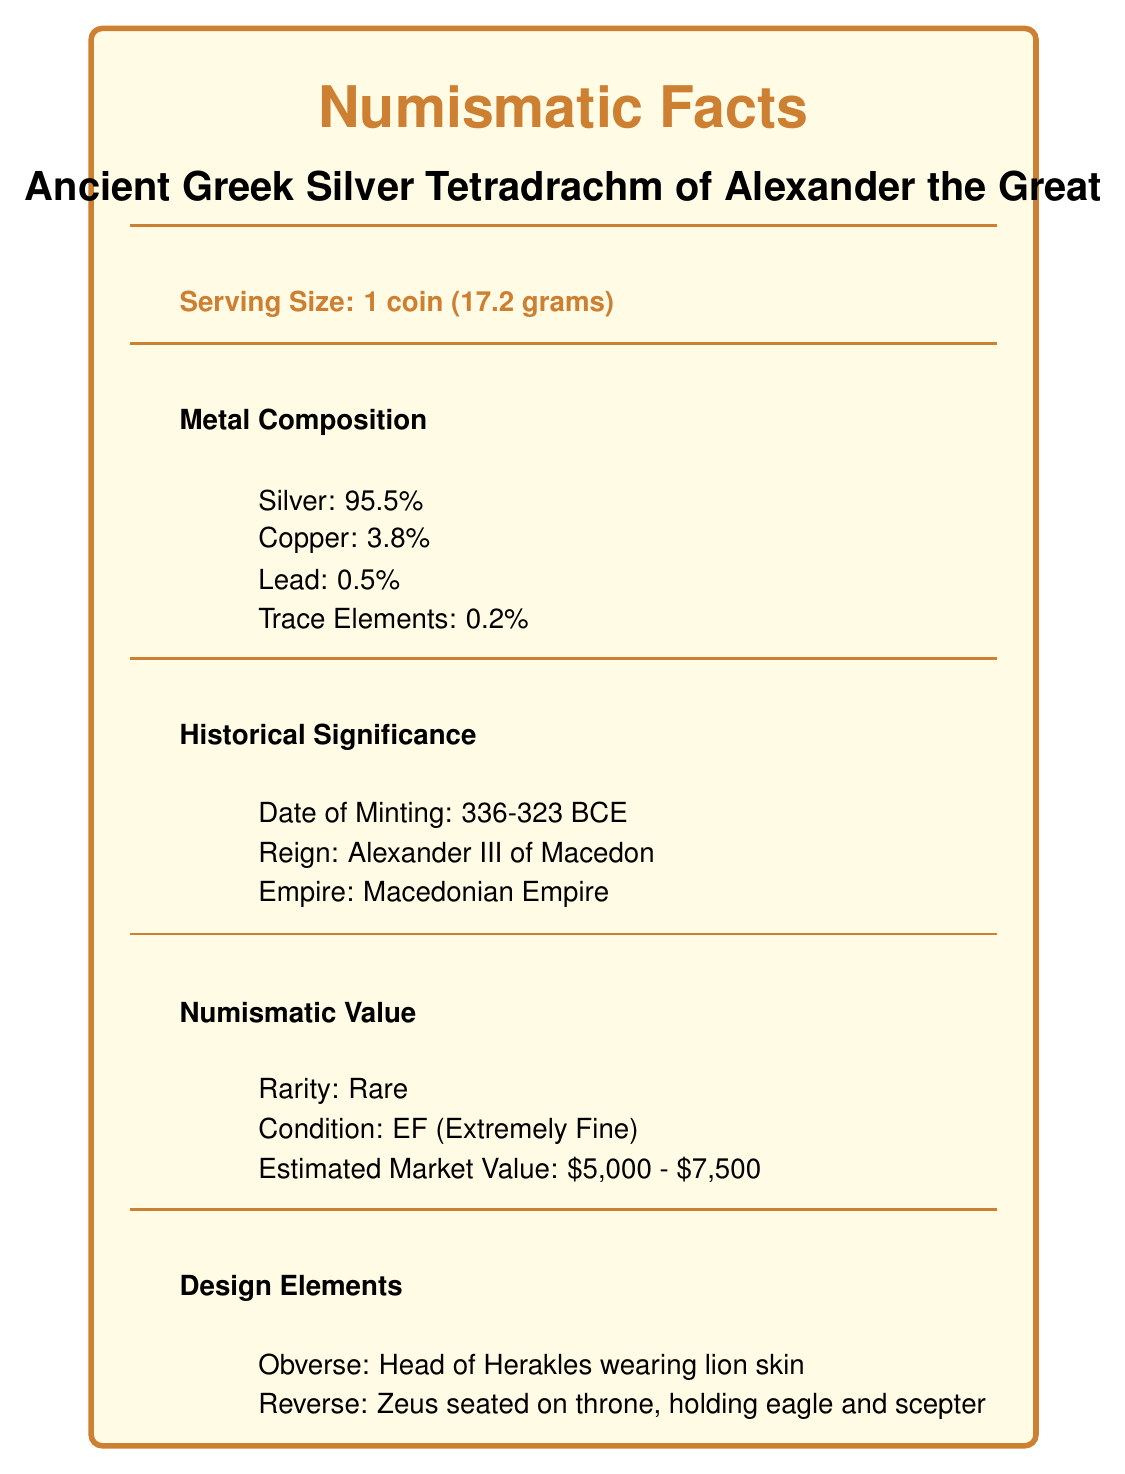what is the serving size of the coin? The serving size is specified in the document as "1 coin (17.2 grams)".
Answer: 1 coin (17.2 grams) what is the silver content percentage in the coin? The metal composition section lists "Silver: 95.5%".
Answer: 95.5% during whose reign was the coin minted? The historical significance section mentions the coin's date of minting during the reign of "Alexander III of Macedon".
Answer: Alexander III of Macedon what is depicted on the obverse side of the coin? The design elements section states "Obverse: Head of Herakles wearing lion skin".
Answer: Head of Herakles wearing lion skin what is the estimated market value of the coin? The numismatic value section lists the "Estimated Market Value: $5,000 - $7,500".
Answer: $5,000 - $7,500 how many trace elements are present in the coin’s composition? A. 0.1% B. 0.2% C. 0.3% D. 0.4% The metal composition section mentions "Trace Elements: 0.2%".
Answer: B. 0.2% which of the following is NOT a metal component listed in the document? A. Silver B. Copper C. Gold D. Lead The document lists Silver, Copper, and Lead but does not mention Gold in the metal composition.
Answer: C. Gold is the coin certified by NGC? The authentication section specifies that the coin is certified by "NGC (Numismatic Guaranty Corporation)".
Answer: Yes is the estimated bidding time for the coin more than 5 minutes? The auction details section indicates "Estimated Bidding Time: 3-5 minutes".
Answer: No summarize the main details of the ancient Greek silver tetradrachm from the document. The summary should include key information about the coin’s weight, metal composition, historical period, design features, numismatic value, provenance, certification, conservation, and cultural significance.
Answer: The ancient Greek silver tetradrachm of Alexander the Great weighs 17.2 grams and contains 95.5% silver. Minted during 336-323 BCE, it features Herakles on the obverse and Zeus on the reverse. The coin is rare, in extremely fine condition, and valued between $5,000 to $7,500. Its provenance includes a private collection in Athens and a previous auction at Sotheby's London in 2015. It is certified by NGC, stored in archival quality holders, and has significant historical and cultural impact. what specific auction house previously sold the coin in 2015? The provenance section indicates the previous auction was at "Sotheby's London, 2015".
Answer: Sotheby's London who was the last known owner of the coin? The provenance section lists the last known owner as "Private collection, Athens".
Answer: Private collection, Athens what is the primary historical context of the coin’s usage? The cultural impact section states the historical context as "Widespread currency of the Hellenistic world".
Answer: Widespread currency of the Hellenistic world can you provide the certificate number from the NGC for the coin? The authentication section provides the certificate number "4862345-002".
Answer: 4862345-002 who is the last known purchaser of this coin? The document does not provide information about the last known purchaser, only the last known owner and previous auction details.
Answer: Cannot be determined 